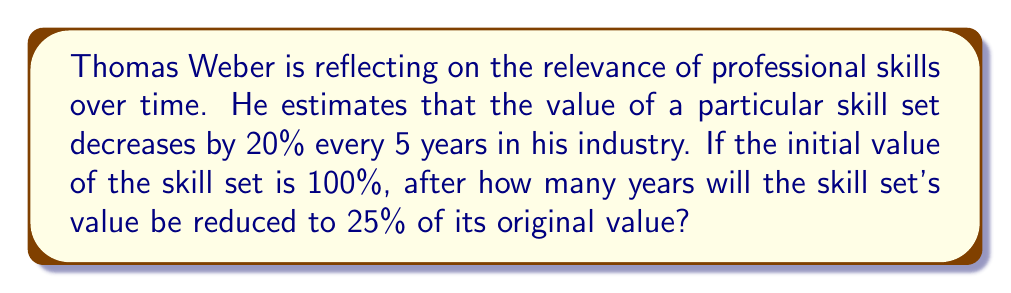Can you answer this question? To solve this problem, we need to use the concept of half-life and exponential decay. Let's approach this step-by-step:

1) The general formula for exponential decay is:

   $A(t) = A_0 \cdot (1-r)^{t/p}$

   Where:
   $A(t)$ is the amount at time $t$
   $A_0$ is the initial amount
   $r$ is the decay rate per period
   $p$ is the length of each period
   $t$ is the time

2) In this case:
   $A_0 = 100\%$
   $r = 20\% = 0.2$
   $p = 5$ years
   $A(t) = 25\%$

3) Plugging these into our equation:

   $25 = 100 \cdot (1-0.2)^{t/5}$

4) Simplify:

   $0.25 = (0.8)^{t/5}$

5) Take the natural log of both sides:

   $\ln(0.25) = \ln((0.8)^{t/5})$

6) Use the log property $\ln(x^n) = n\ln(x)$:

   $\ln(0.25) = \frac{t}{5}\ln(0.8)$

7) Solve for $t$:

   $t = \frac{5\ln(0.25)}{\ln(0.8)} \approx 33.42$ years

8) Round to the nearest whole number of years:

   $t \approx 33$ years
Answer: It will take approximately 33 years for the skill set's value to be reduced to 25% of its original value. 